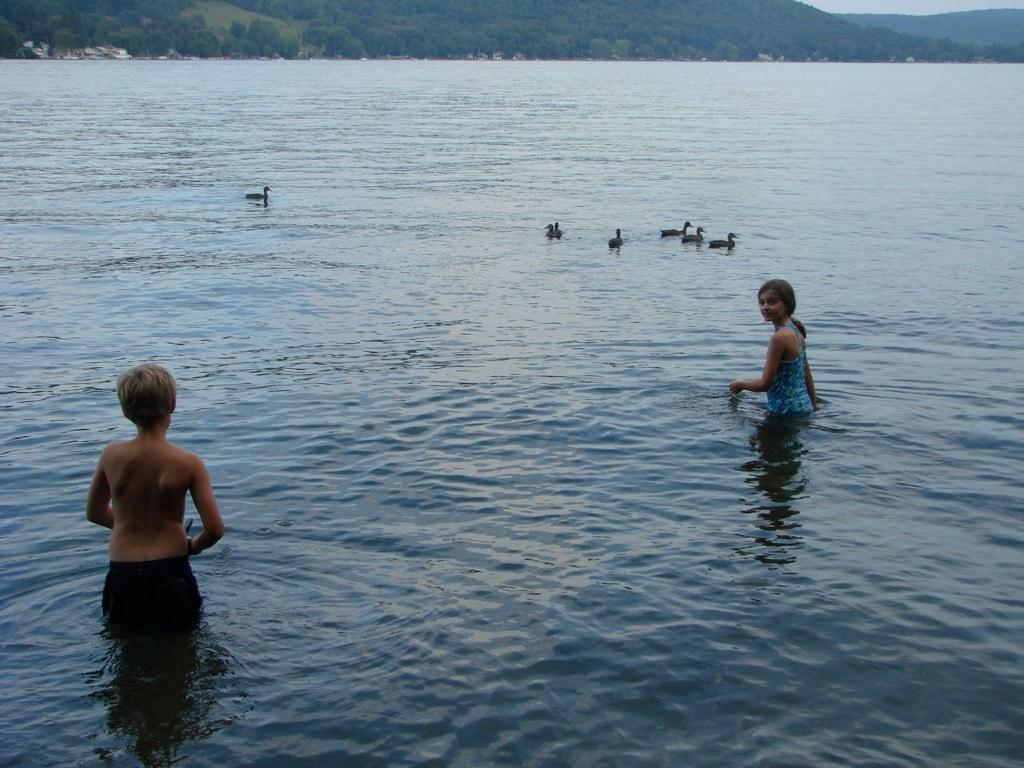What are the two people in the image doing? The two people are standing in the river. What animals can be seen on the water in the image? There are ducks on the water in the image. What can be seen in the distance behind the people and ducks? Hills and the sky are visible in the background. What type of property does the person in the image own? There is no information about property ownership in the image. Can you describe the facial expressions of the people in the image? The image does not show the faces of the people, so their facial expressions cannot be determined. 